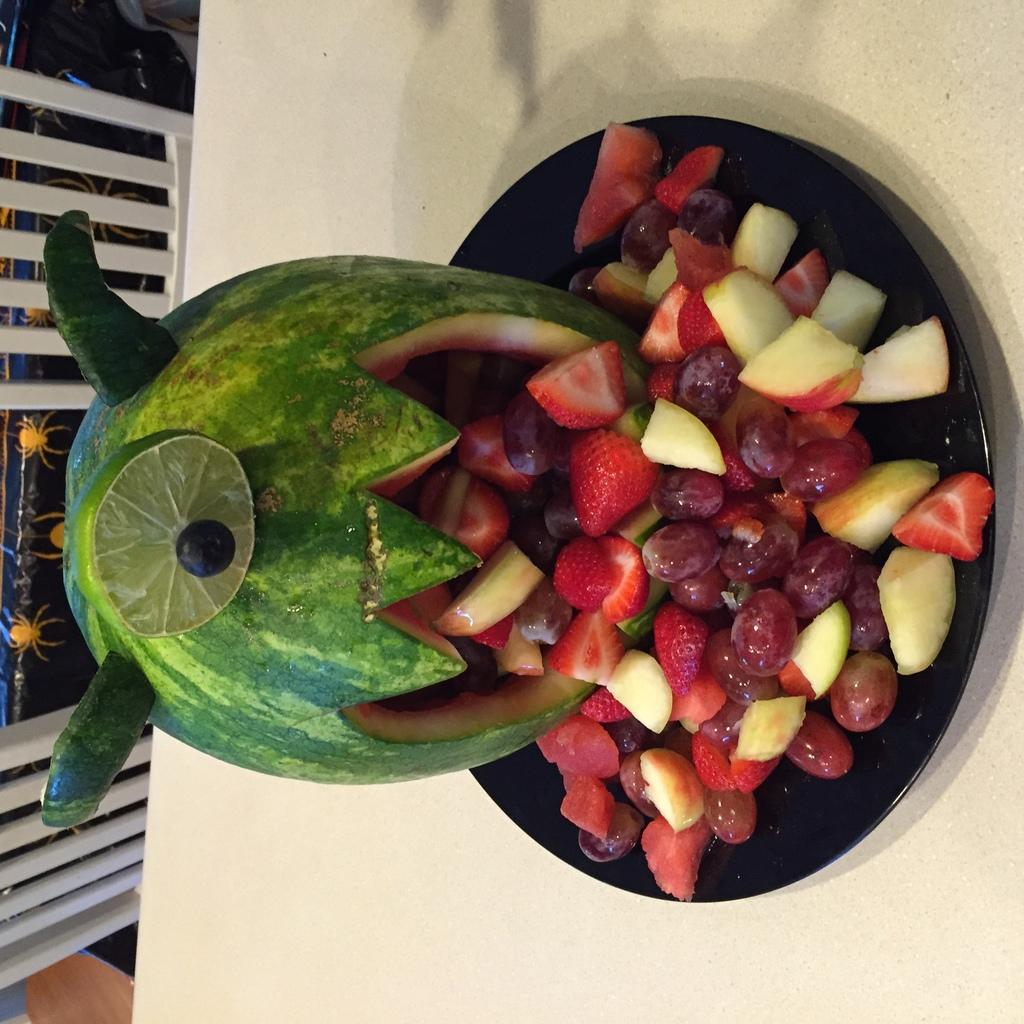What type of food is in the center of the image? There are fruits in the center of the image. Can you name some specific fruits that are present? Yes, the fruits include strawberries and apples. Are there any other types of fruits in the image besides strawberries and apples? Yes, there are other unspecified fruits in the image. What type of wood is used to construct the mind in the image? There is no wood or mind present in the image; it features fruits. 